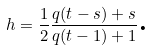<formula> <loc_0><loc_0><loc_500><loc_500>h = \frac { 1 } { 2 } \frac { q ( t - s ) + s } { q ( t - 1 ) + 1 } \text {.}</formula> 